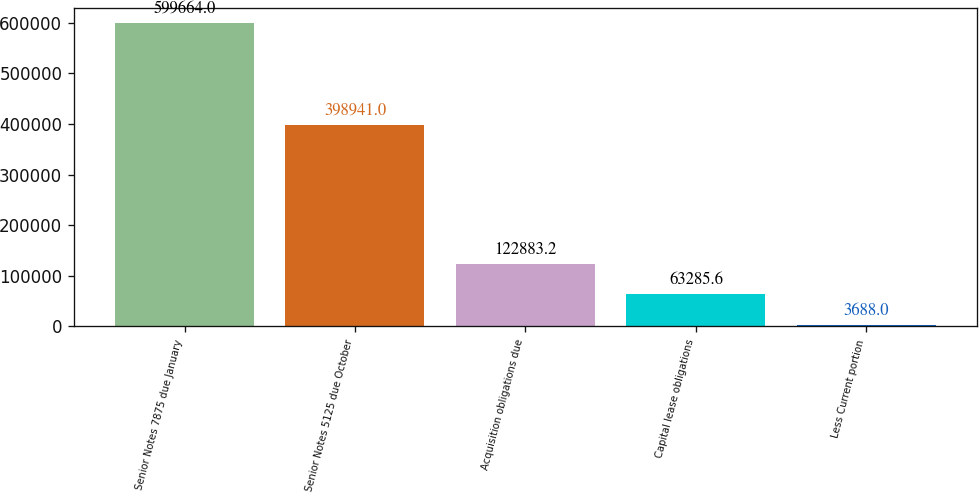<chart> <loc_0><loc_0><loc_500><loc_500><bar_chart><fcel>Senior Notes 7875 due January<fcel>Senior Notes 5125 due October<fcel>Acquisition obligations due<fcel>Capital lease obligations<fcel>Less Current portion<nl><fcel>599664<fcel>398941<fcel>122883<fcel>63285.6<fcel>3688<nl></chart> 